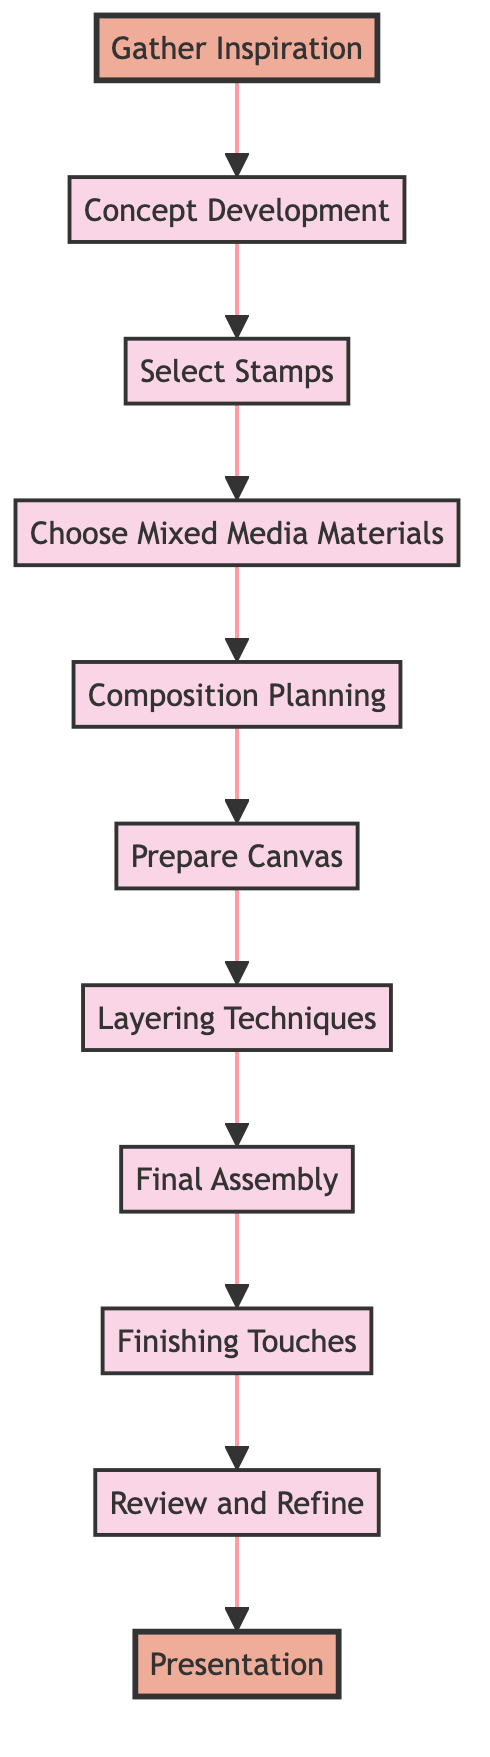What is the first step in the design process? The first node in the flow chart is "Gather Inspiration," which indicates it is the initial step of the design process for creating a unique stamp collection art piece.
Answer: Gather Inspiration How many nodes are there in the diagram? By counting each individual step in the flow chart, there are a total of 11 nodes representing different stages of the design process.
Answer: 11 Which step comes immediately after "Select Stamps"? The flowchart shows that "Choose Mixed Media Materials" is the next step following "Select Stamps," directly connected in the sequence.
Answer: Choose Mixed Media Materials What is the last step in the design process? The final node in the flow chart is "Presentation," indicating it is the concluding step after completing the artwork.
Answer: Presentation What is the relationship between "Layering Techniques" and "Final Assembly"? In the flow chart, "Layering Techniques" directly leads into "Final Assembly," indicating that the assembly occurs after layering.
Answer: Sequential How many steps are there before "Finishing Touches"? To reach "Finishing Touches," one must pass through 9 previous steps, showing how many processes are involved before finalizing the artwork.
Answer: 9 What is the significance of the highlighted nodes? The highlighted nodes represent the beginning ("Gather Inspiration") and the end ("Presentation") of the design process, emphasizing the overall flow progression.
Answer: Start and End What connects "Composition Planning" to "Prepare Canvas"? The diagram shows an arrow directing from "Composition Planning" to "Prepare Canvas," which represents a sequential flow from planning to preparation.
Answer: Direct connection How does "Review and Refine" relate to "Final Assembly"? The flowchart indicates that "Review and Refine" occurs after "Final Assembly," suggesting that reviewing happens once assembly is complete.
Answer: Post-assembly review 